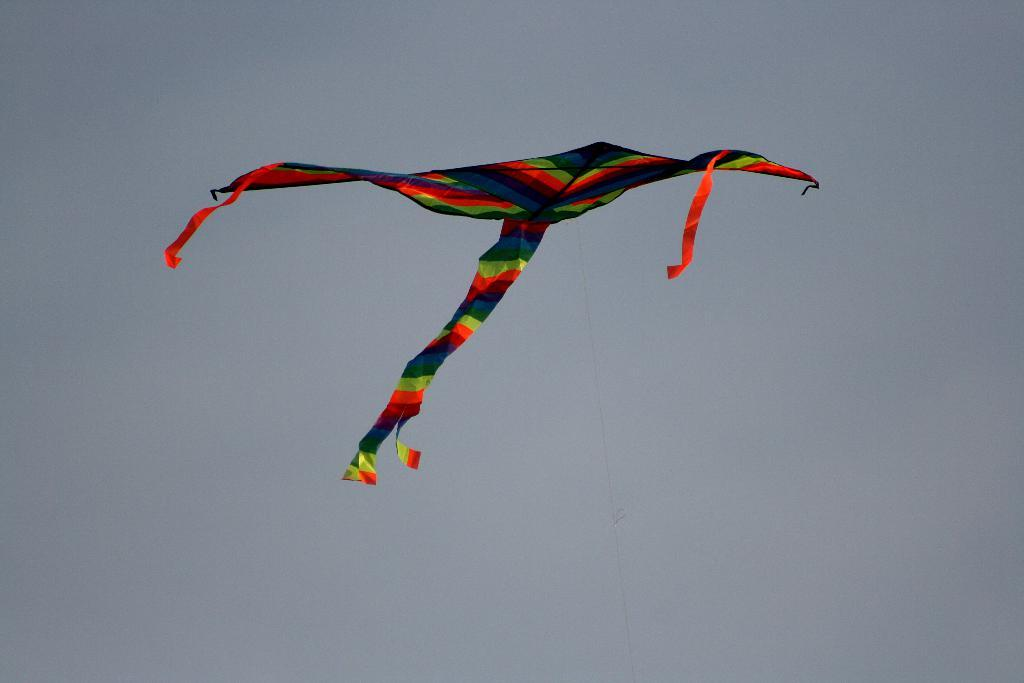What object can be seen in the image that is flying in the air? There is a kite in the image that is flying in the air. What is visible behind the kite in the image? The sky is visible behind the kite in the image. Where is the library located in the image? There is no library present in the image. What type of glue is being used to hold the kite together in the image? There is no glue visible in the image, and the kite's construction is not mentioned in the provided facts. 